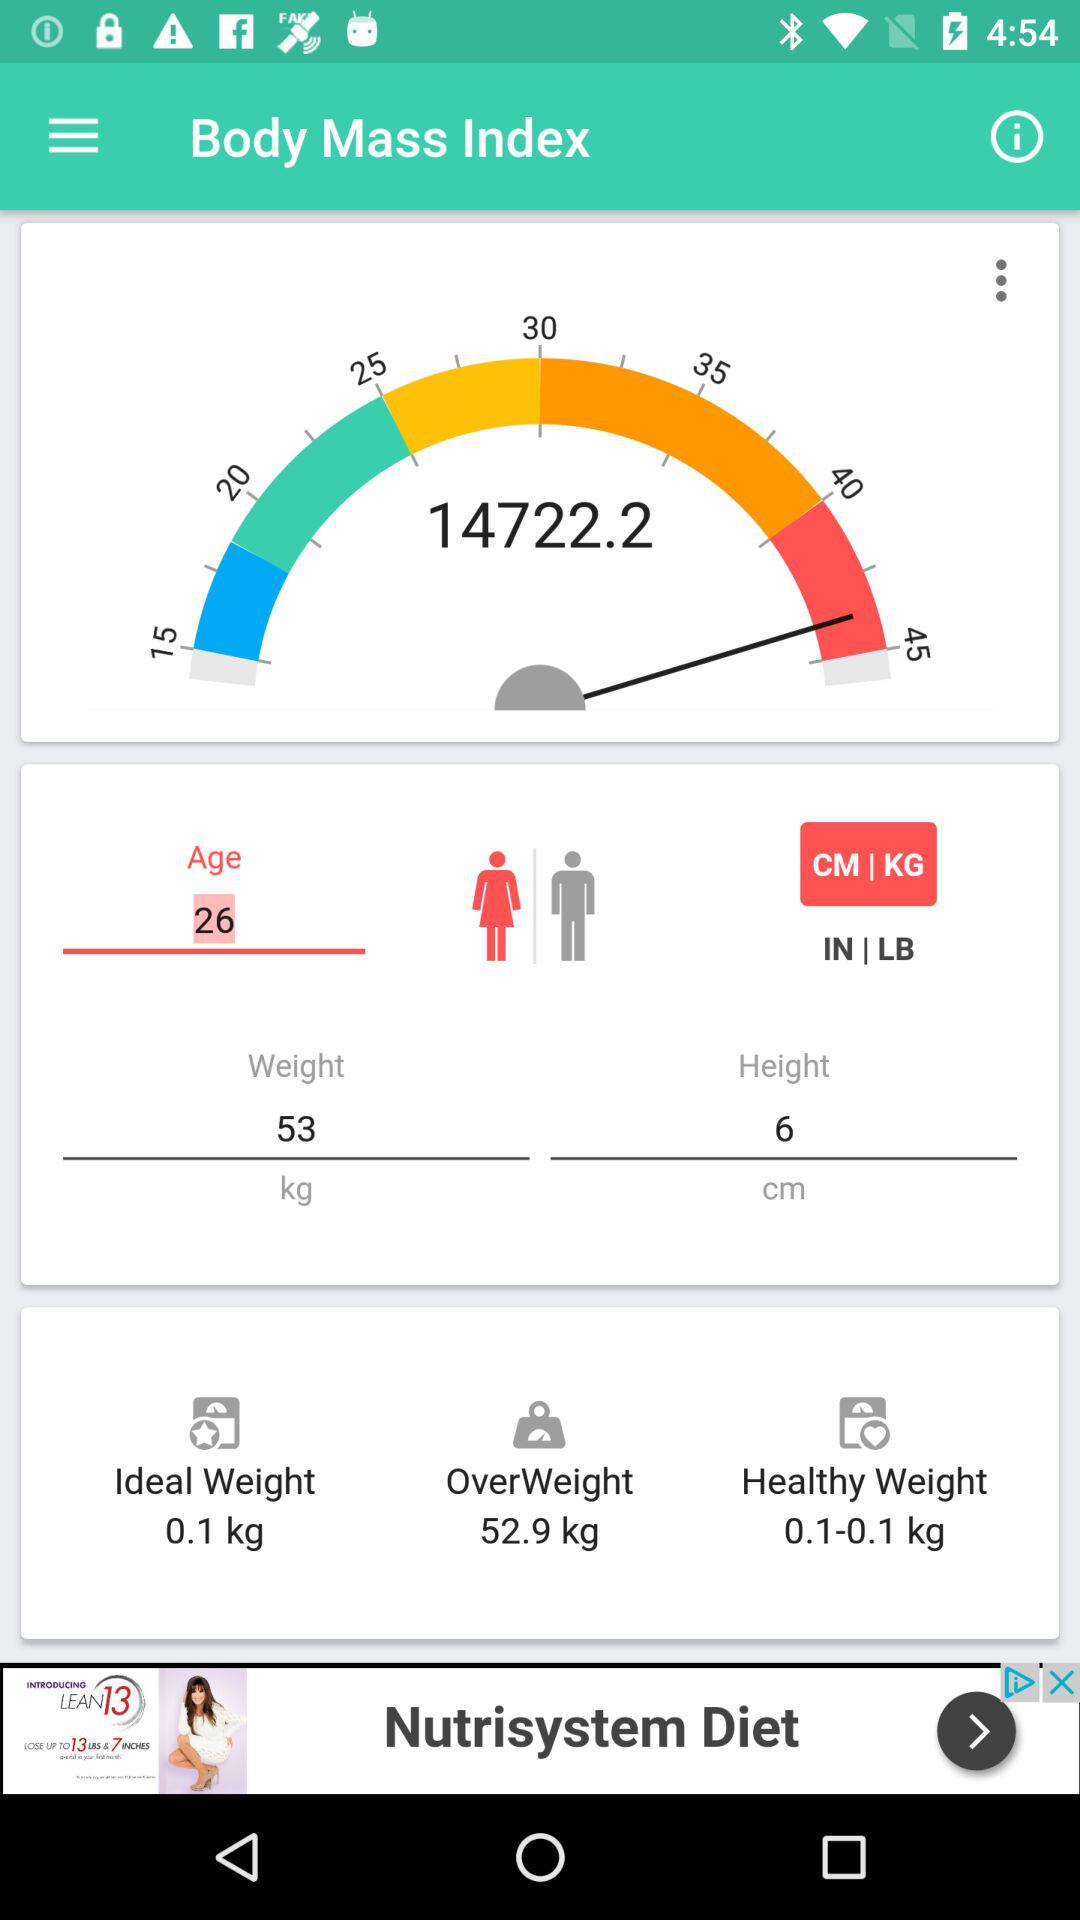What is the healthy weight range? The healthy weight range is 0.1 to 0.1 kg. 